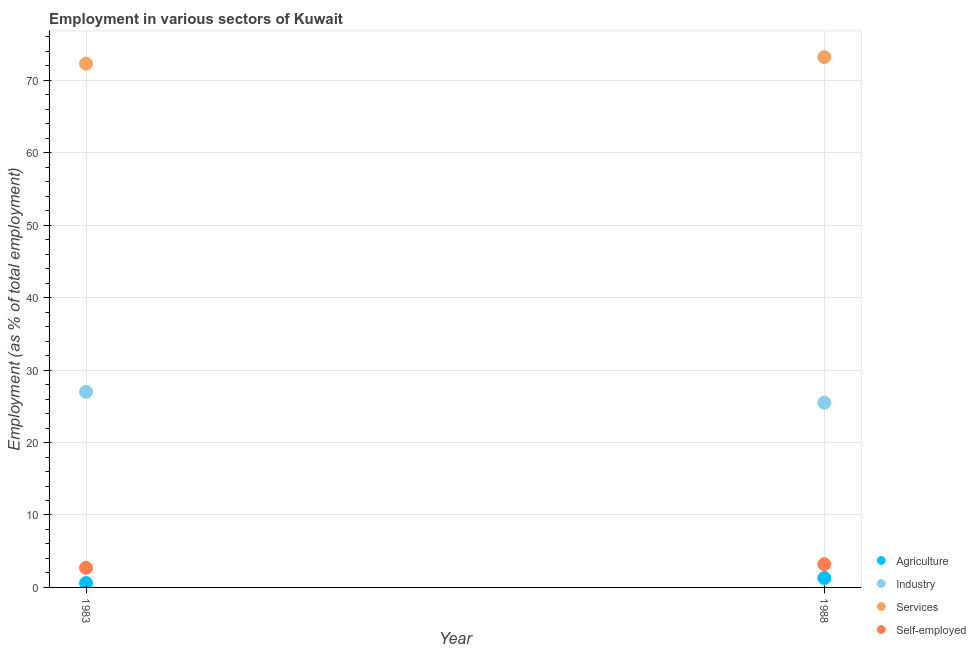How many different coloured dotlines are there?
Offer a very short reply. 4. Is the number of dotlines equal to the number of legend labels?
Your answer should be very brief. Yes. What is the percentage of workers in services in 1983?
Keep it short and to the point. 72.3. Across all years, what is the maximum percentage of workers in services?
Provide a short and direct response. 73.2. Across all years, what is the minimum percentage of self employed workers?
Provide a succinct answer. 2.7. What is the total percentage of self employed workers in the graph?
Your response must be concise. 5.9. What is the difference between the percentage of workers in services in 1983 and that in 1988?
Provide a succinct answer. -0.9. What is the difference between the percentage of workers in agriculture in 1983 and the percentage of workers in services in 1988?
Ensure brevity in your answer.  -72.6. What is the average percentage of workers in industry per year?
Provide a succinct answer. 26.25. In the year 1988, what is the difference between the percentage of workers in services and percentage of workers in industry?
Keep it short and to the point. 47.7. In how many years, is the percentage of self employed workers greater than 8 %?
Provide a short and direct response. 0. What is the ratio of the percentage of self employed workers in 1983 to that in 1988?
Make the answer very short. 0.84. Is the percentage of workers in industry in 1983 less than that in 1988?
Give a very brief answer. No. In how many years, is the percentage of workers in industry greater than the average percentage of workers in industry taken over all years?
Make the answer very short. 1. Does the percentage of workers in services monotonically increase over the years?
Your answer should be very brief. Yes. Is the percentage of workers in industry strictly greater than the percentage of self employed workers over the years?
Offer a terse response. Yes. How many years are there in the graph?
Make the answer very short. 2. What is the difference between two consecutive major ticks on the Y-axis?
Keep it short and to the point. 10. Where does the legend appear in the graph?
Keep it short and to the point. Bottom right. How many legend labels are there?
Provide a succinct answer. 4. What is the title of the graph?
Give a very brief answer. Employment in various sectors of Kuwait. Does "France" appear as one of the legend labels in the graph?
Your answer should be very brief. No. What is the label or title of the X-axis?
Keep it short and to the point. Year. What is the label or title of the Y-axis?
Offer a terse response. Employment (as % of total employment). What is the Employment (as % of total employment) of Agriculture in 1983?
Provide a short and direct response. 0.6. What is the Employment (as % of total employment) of Industry in 1983?
Ensure brevity in your answer.  27. What is the Employment (as % of total employment) of Services in 1983?
Offer a terse response. 72.3. What is the Employment (as % of total employment) of Self-employed in 1983?
Your response must be concise. 2.7. What is the Employment (as % of total employment) of Agriculture in 1988?
Provide a short and direct response. 1.3. What is the Employment (as % of total employment) in Industry in 1988?
Provide a short and direct response. 25.5. What is the Employment (as % of total employment) of Services in 1988?
Your answer should be very brief. 73.2. What is the Employment (as % of total employment) in Self-employed in 1988?
Offer a terse response. 3.2. Across all years, what is the maximum Employment (as % of total employment) in Agriculture?
Your answer should be compact. 1.3. Across all years, what is the maximum Employment (as % of total employment) of Industry?
Your answer should be very brief. 27. Across all years, what is the maximum Employment (as % of total employment) in Services?
Your response must be concise. 73.2. Across all years, what is the maximum Employment (as % of total employment) of Self-employed?
Your answer should be compact. 3.2. Across all years, what is the minimum Employment (as % of total employment) of Agriculture?
Offer a very short reply. 0.6. Across all years, what is the minimum Employment (as % of total employment) of Services?
Keep it short and to the point. 72.3. Across all years, what is the minimum Employment (as % of total employment) of Self-employed?
Your response must be concise. 2.7. What is the total Employment (as % of total employment) of Industry in the graph?
Offer a terse response. 52.5. What is the total Employment (as % of total employment) of Services in the graph?
Give a very brief answer. 145.5. What is the difference between the Employment (as % of total employment) of Industry in 1983 and that in 1988?
Provide a short and direct response. 1.5. What is the difference between the Employment (as % of total employment) of Agriculture in 1983 and the Employment (as % of total employment) of Industry in 1988?
Offer a terse response. -24.9. What is the difference between the Employment (as % of total employment) of Agriculture in 1983 and the Employment (as % of total employment) of Services in 1988?
Provide a short and direct response. -72.6. What is the difference between the Employment (as % of total employment) of Agriculture in 1983 and the Employment (as % of total employment) of Self-employed in 1988?
Ensure brevity in your answer.  -2.6. What is the difference between the Employment (as % of total employment) of Industry in 1983 and the Employment (as % of total employment) of Services in 1988?
Your answer should be compact. -46.2. What is the difference between the Employment (as % of total employment) in Industry in 1983 and the Employment (as % of total employment) in Self-employed in 1988?
Ensure brevity in your answer.  23.8. What is the difference between the Employment (as % of total employment) in Services in 1983 and the Employment (as % of total employment) in Self-employed in 1988?
Give a very brief answer. 69.1. What is the average Employment (as % of total employment) of Agriculture per year?
Offer a very short reply. 0.95. What is the average Employment (as % of total employment) of Industry per year?
Offer a very short reply. 26.25. What is the average Employment (as % of total employment) in Services per year?
Provide a succinct answer. 72.75. What is the average Employment (as % of total employment) in Self-employed per year?
Provide a succinct answer. 2.95. In the year 1983, what is the difference between the Employment (as % of total employment) in Agriculture and Employment (as % of total employment) in Industry?
Your answer should be compact. -26.4. In the year 1983, what is the difference between the Employment (as % of total employment) in Agriculture and Employment (as % of total employment) in Services?
Offer a terse response. -71.7. In the year 1983, what is the difference between the Employment (as % of total employment) in Agriculture and Employment (as % of total employment) in Self-employed?
Your answer should be very brief. -2.1. In the year 1983, what is the difference between the Employment (as % of total employment) of Industry and Employment (as % of total employment) of Services?
Your answer should be very brief. -45.3. In the year 1983, what is the difference between the Employment (as % of total employment) in Industry and Employment (as % of total employment) in Self-employed?
Make the answer very short. 24.3. In the year 1983, what is the difference between the Employment (as % of total employment) in Services and Employment (as % of total employment) in Self-employed?
Keep it short and to the point. 69.6. In the year 1988, what is the difference between the Employment (as % of total employment) in Agriculture and Employment (as % of total employment) in Industry?
Make the answer very short. -24.2. In the year 1988, what is the difference between the Employment (as % of total employment) of Agriculture and Employment (as % of total employment) of Services?
Provide a succinct answer. -71.9. In the year 1988, what is the difference between the Employment (as % of total employment) of Agriculture and Employment (as % of total employment) of Self-employed?
Provide a short and direct response. -1.9. In the year 1988, what is the difference between the Employment (as % of total employment) in Industry and Employment (as % of total employment) in Services?
Offer a terse response. -47.7. In the year 1988, what is the difference between the Employment (as % of total employment) of Industry and Employment (as % of total employment) of Self-employed?
Provide a short and direct response. 22.3. In the year 1988, what is the difference between the Employment (as % of total employment) of Services and Employment (as % of total employment) of Self-employed?
Ensure brevity in your answer.  70. What is the ratio of the Employment (as % of total employment) of Agriculture in 1983 to that in 1988?
Your answer should be compact. 0.46. What is the ratio of the Employment (as % of total employment) in Industry in 1983 to that in 1988?
Provide a short and direct response. 1.06. What is the ratio of the Employment (as % of total employment) of Self-employed in 1983 to that in 1988?
Your response must be concise. 0.84. What is the difference between the highest and the second highest Employment (as % of total employment) in Agriculture?
Keep it short and to the point. 0.7. What is the difference between the highest and the second highest Employment (as % of total employment) of Services?
Give a very brief answer. 0.9. What is the difference between the highest and the second highest Employment (as % of total employment) of Self-employed?
Your answer should be very brief. 0.5. What is the difference between the highest and the lowest Employment (as % of total employment) in Industry?
Give a very brief answer. 1.5. 